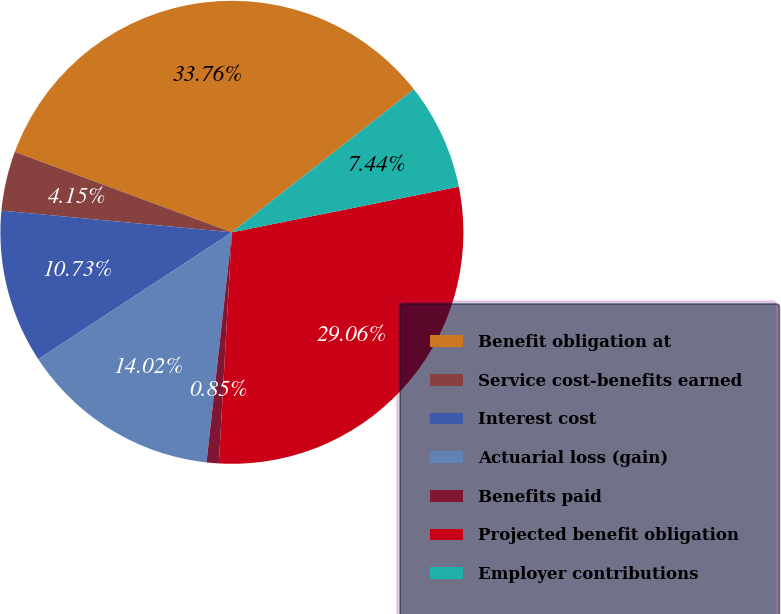Convert chart to OTSL. <chart><loc_0><loc_0><loc_500><loc_500><pie_chart><fcel>Benefit obligation at<fcel>Service cost-benefits earned<fcel>Interest cost<fcel>Actuarial loss (gain)<fcel>Benefits paid<fcel>Projected benefit obligation<fcel>Employer contributions<nl><fcel>33.76%<fcel>4.15%<fcel>10.73%<fcel>14.02%<fcel>0.85%<fcel>29.06%<fcel>7.44%<nl></chart> 